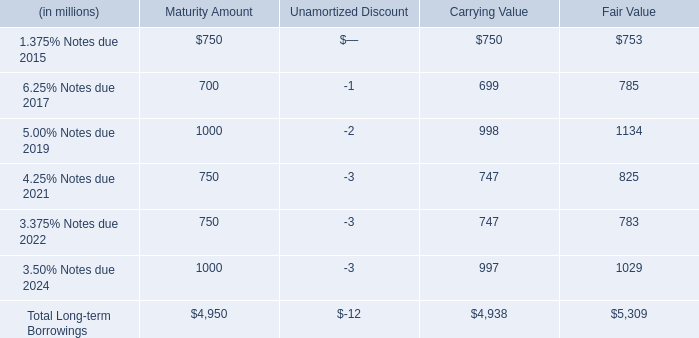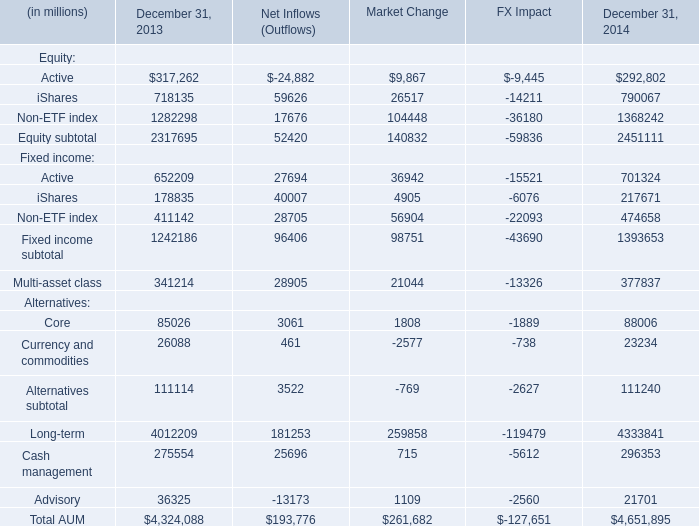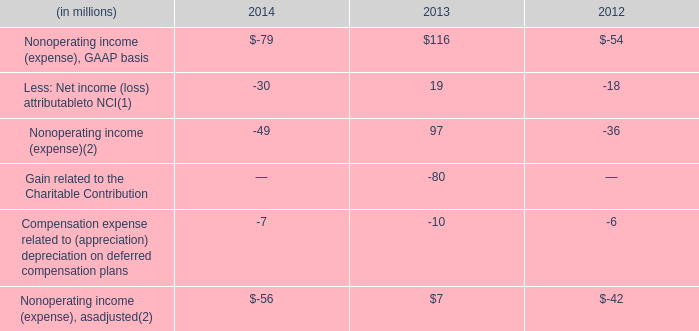what portion of total long-term borrowings is due in the next 36 months? 
Computations: ((750 + 700) / 4950)
Answer: 0.29293. 